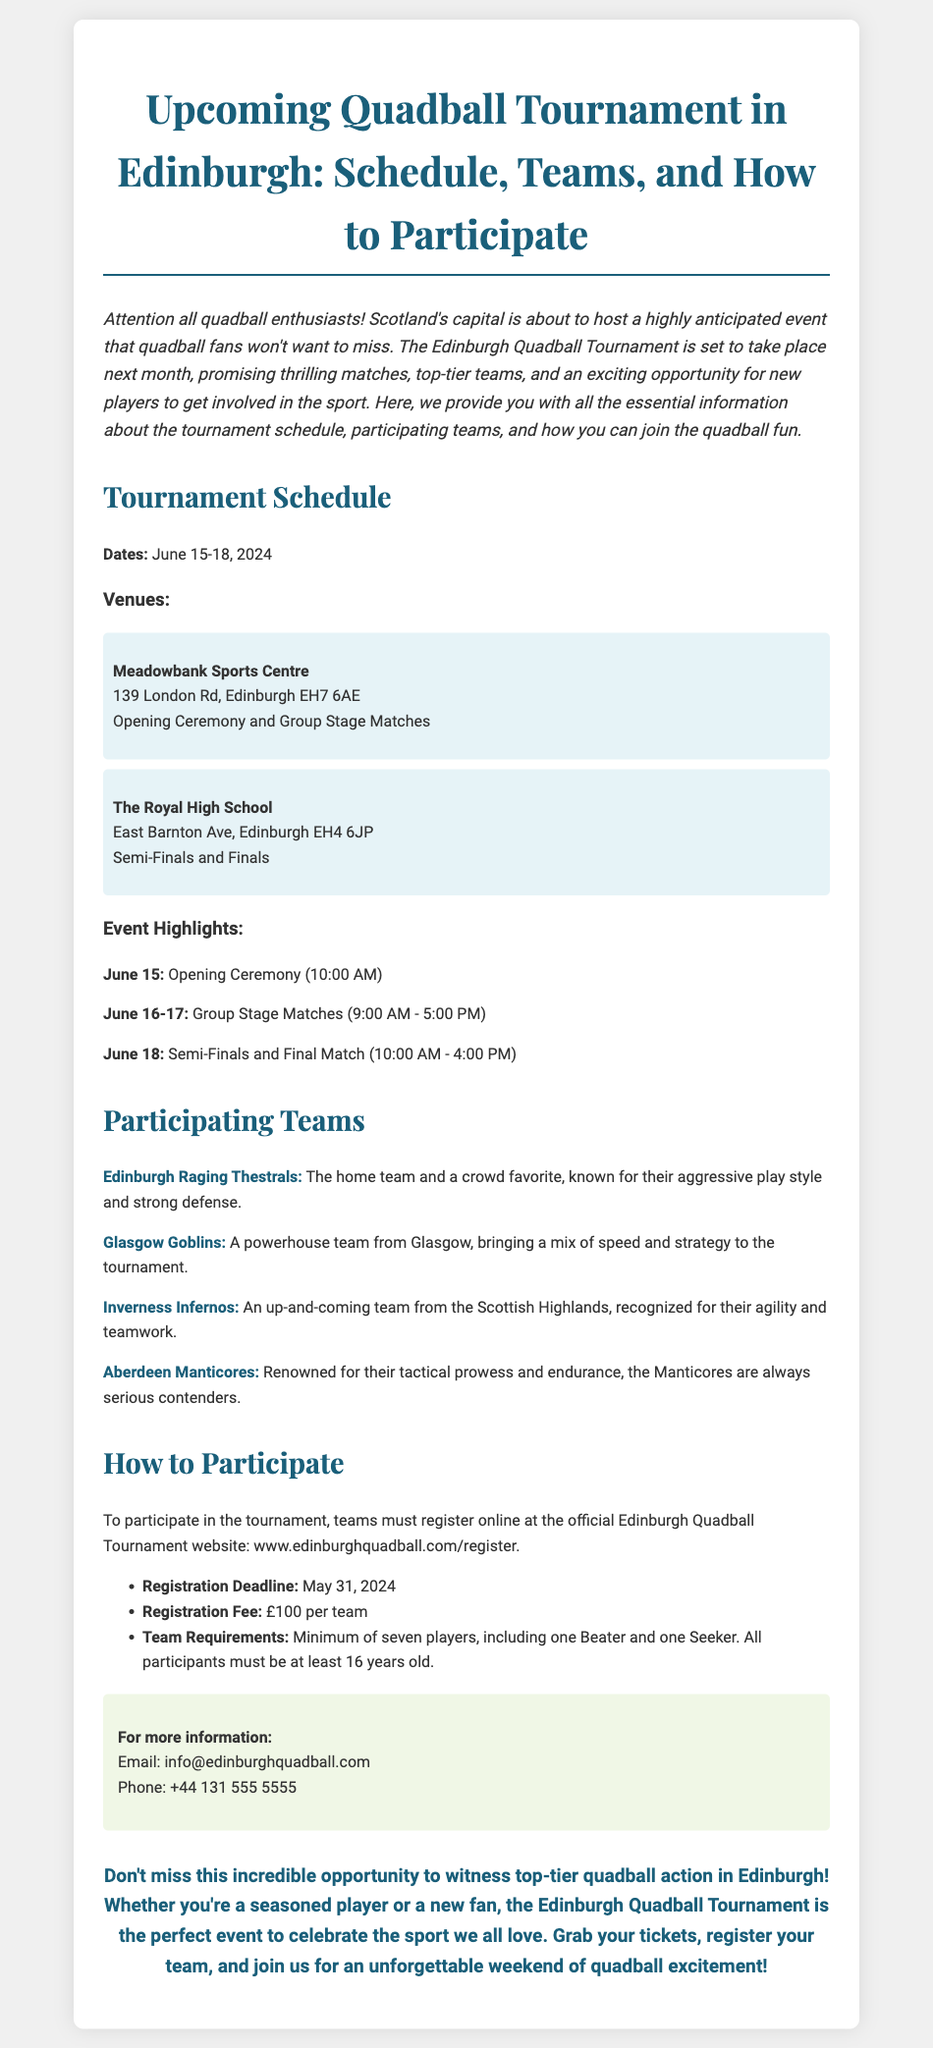What are the tournament dates? The tournament dates are explicitly mentioned in the document as June 15-18, 2024.
Answer: June 15-18, 2024 Where is the opening ceremony taking place? The document specifies that the opening ceremony will be held at Meadowbank Sports Centre.
Answer: Meadowbank Sports Centre What is the registration deadline for teams? The deadline for registration is clearly stated in the document, which is May 31, 2024.
Answer: May 31, 2024 How many players are required on a team? The document outlines the team requirement that specifies a minimum of seven players must be on each team.
Answer: Seven players Which team is the home team? The document indicates that the "Edinburgh Raging Thestrals" is the home team.
Answer: Edinburgh Raging Thestrals What is the registration fee per team? The registration fee is mentioned directly in the document as £100 per team.
Answer: £100 What time do the group stage matches start? The document provides the starting time for group stage matches as 9:00 AM.
Answer: 9:00 AM Where can teams register for the tournament? The document provides a specific website where teams can register, which is www.edinburghquadball.com/register.
Answer: www.edinburghquadball.com/register What is one highlight of the tournament? The document lists several highlights, including the opening ceremony on June 15 at 10:00 AM.
Answer: Opening Ceremony (10:00 AM) 